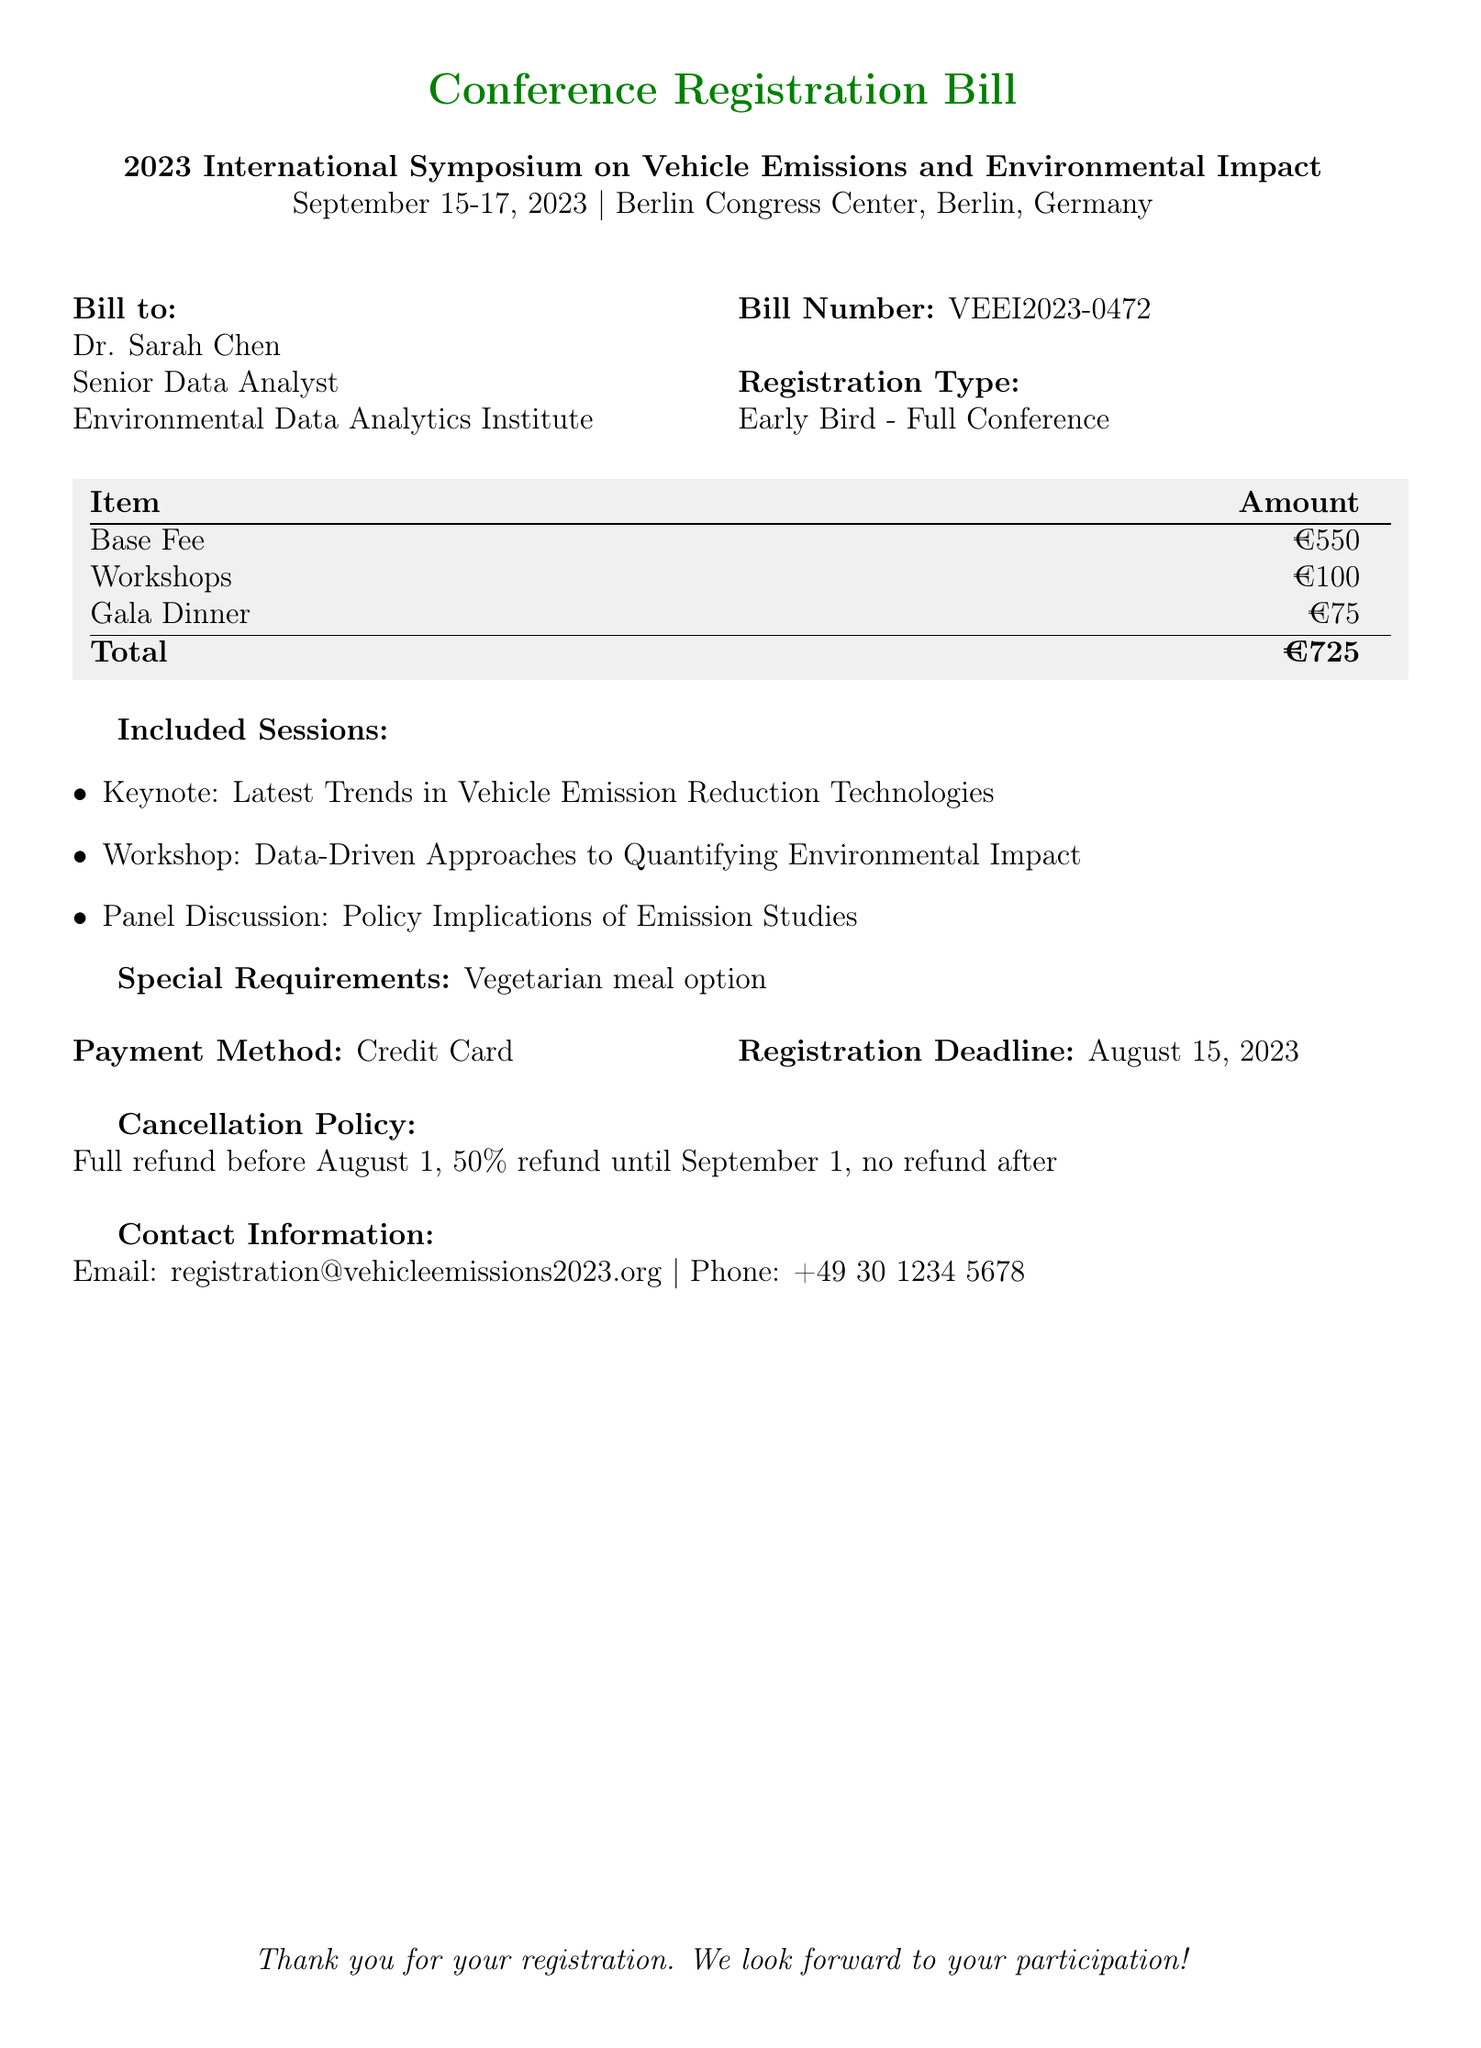what is the bill number? The bill number is explicitly mentioned in the document under "Bill Number".
Answer: VEEI2023-0472 what is the total amount due? The total amount due is found at the end of the itemized list in the document.
Answer: €725 who is the bill addressed to? The name of the person the bill is addressed to is listed under "Bill to".
Answer: Dr. Sarah Chen what is the registration deadline? The registration deadline is mentioned in the payment details section of the document.
Answer: August 15, 2023 how much is the base fee for the conference? The base fee is clearly stated in the itemized list.
Answer: €550 what is the cancellation policy after September 1? The policy clarifies the refund process before and after September 1.
Answer: no refund after what meal option was requested? The request for a specific meal option is indicated in the special requirements section.
Answer: Vegetarian meal option what type of payment method is accepted? The payment method is specified under payment details.
Answer: Credit Card how many days will the conference take place? The duration of the event is mentioned at the top of the document.
Answer: 3 days 